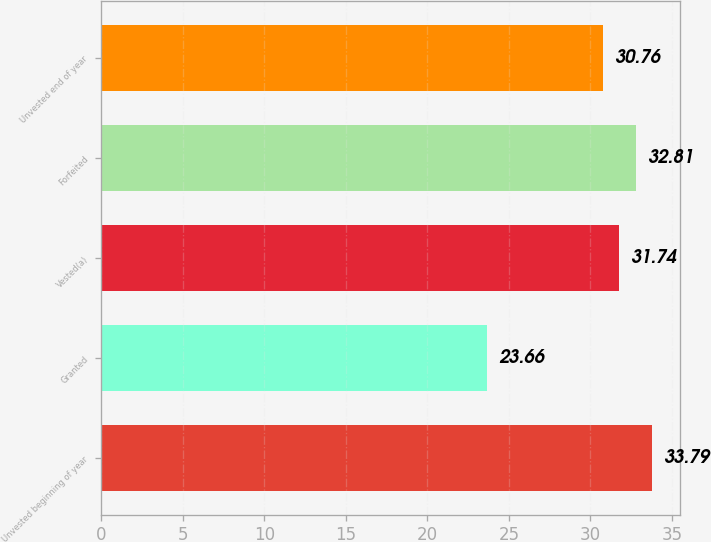Convert chart. <chart><loc_0><loc_0><loc_500><loc_500><bar_chart><fcel>Unvested beginning of year<fcel>Granted<fcel>Vested(a)<fcel>Forfeited<fcel>Unvested end of year<nl><fcel>33.79<fcel>23.66<fcel>31.74<fcel>32.81<fcel>30.76<nl></chart> 